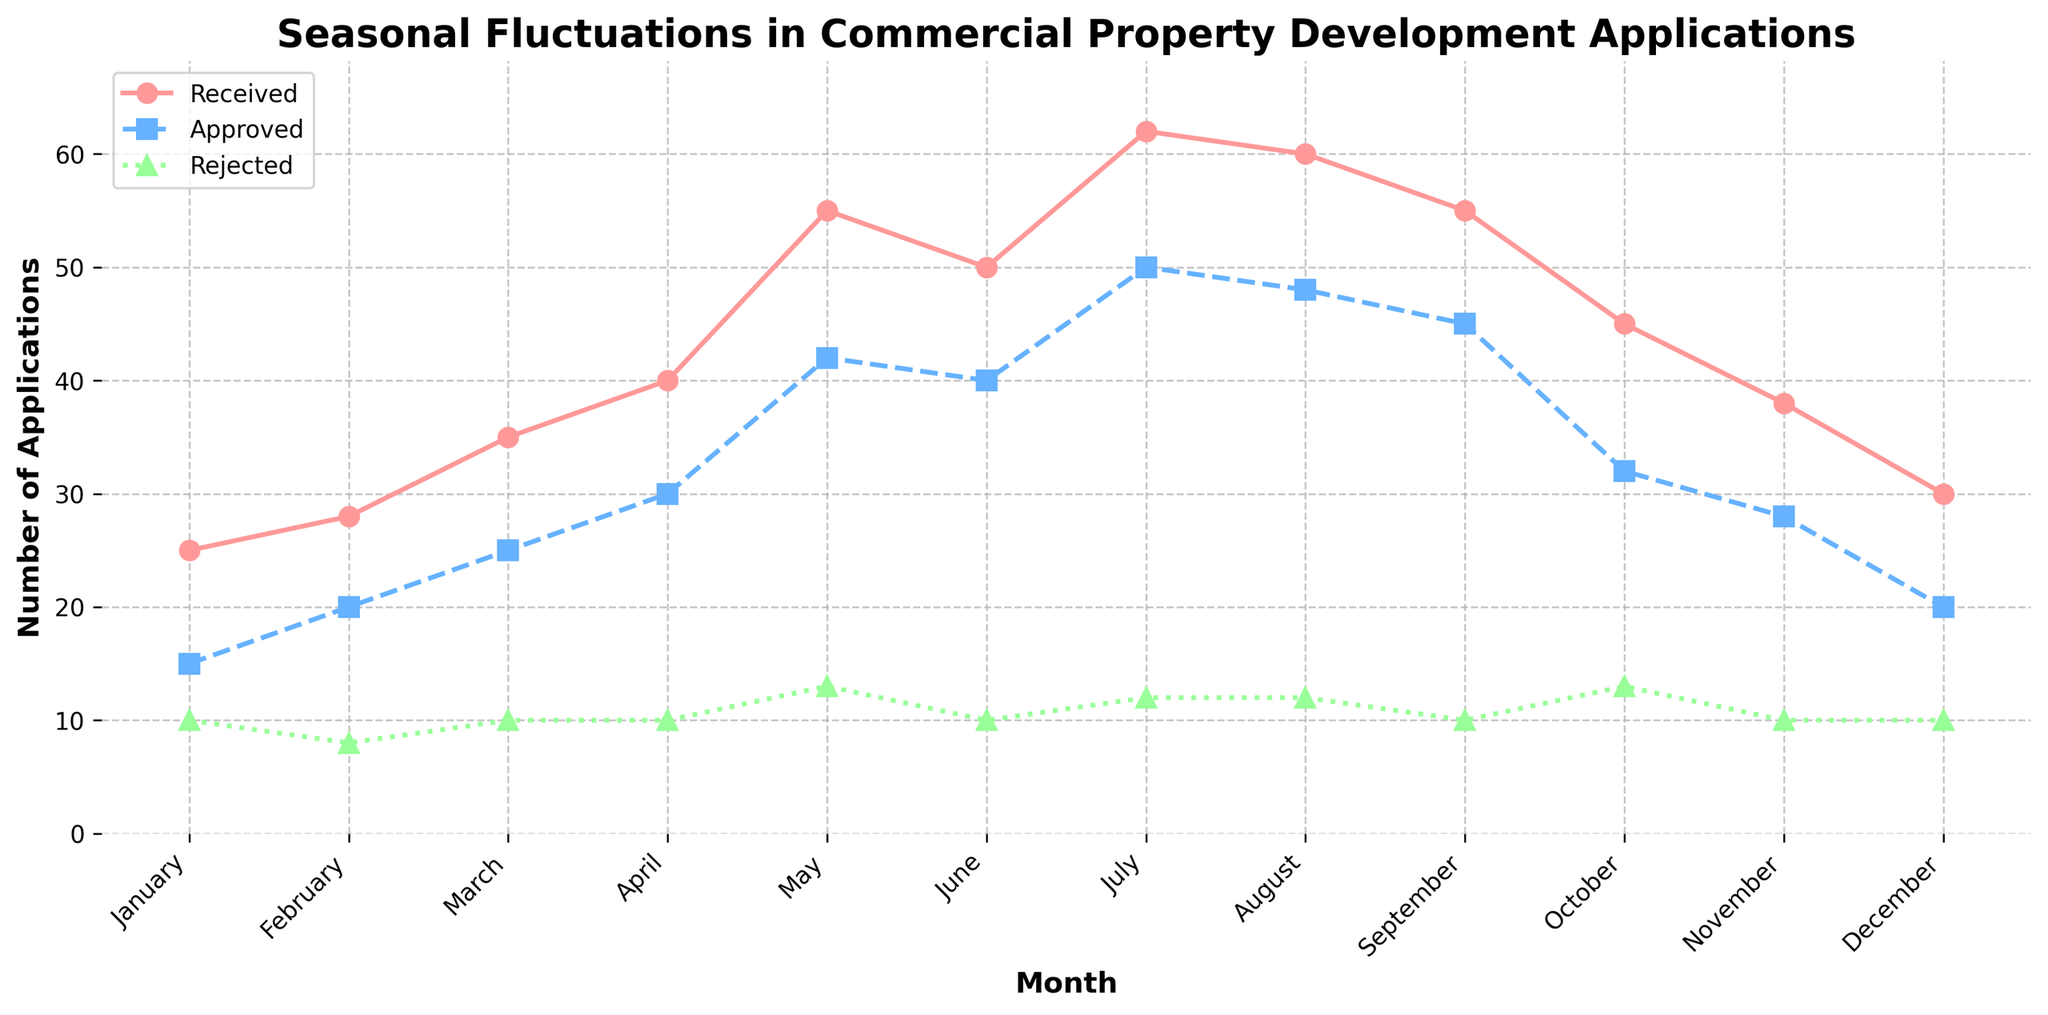What is the title of the plot? The title is displayed at the top of the plot in bold.
Answer: Seasonal Fluctuations in Commercial Property Development Applications In which month were the most applications approved? Identify the highest point on the 'Approved' curve, represented by square markers.
Answer: July How many applications were received in May? Locate May on the x-axis and read the value where the 'Received' line intersects.
Answer: 55 Which month shows the smallest difference between approved and rejected applications? Calculate the difference for each month and identify the smallest.
Answer: November What is the average number of applications received over the year? Sum all the 'Received' values and divide by the number of months (12).
Answer: 44.67 In which month were rejected applications the highest? Identify the highest point on the 'Rejected' curve, represented by triangles.
Answer: May and October How many more applications were approved than rejected in June? Subtract the number of rejected applications in June from the number of approved applications in June (40 - 10).
Answer: 30 Which month shows a peak in received applications? Identify the highest point on the 'Received' curve.
Answer: July What is the general trend in the number of received applications from January to July? Observe the 'Received' line and note if it is increasing, decreasing, or constant from January to July.
Answer: Increasing How do the number of applications received in February compare to those in December? Compare the values for 'Received' applications in February and December.
Answer: February (28) is higher than December (30) 